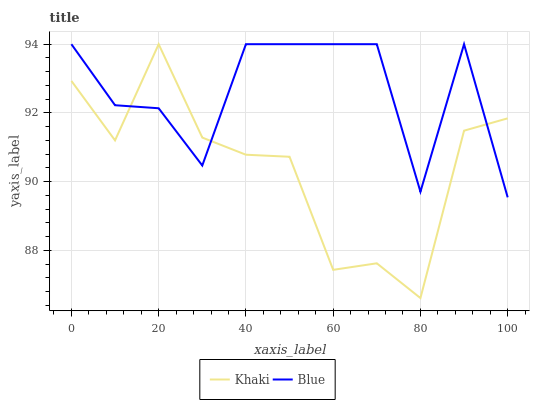Does Khaki have the minimum area under the curve?
Answer yes or no. Yes. Does Blue have the maximum area under the curve?
Answer yes or no. Yes. Does Khaki have the maximum area under the curve?
Answer yes or no. No. Is Khaki the smoothest?
Answer yes or no. Yes. Is Blue the roughest?
Answer yes or no. Yes. Is Khaki the roughest?
Answer yes or no. No. Does Khaki have the lowest value?
Answer yes or no. Yes. Does Khaki have the highest value?
Answer yes or no. Yes. Does Blue intersect Khaki?
Answer yes or no. Yes. Is Blue less than Khaki?
Answer yes or no. No. Is Blue greater than Khaki?
Answer yes or no. No. 